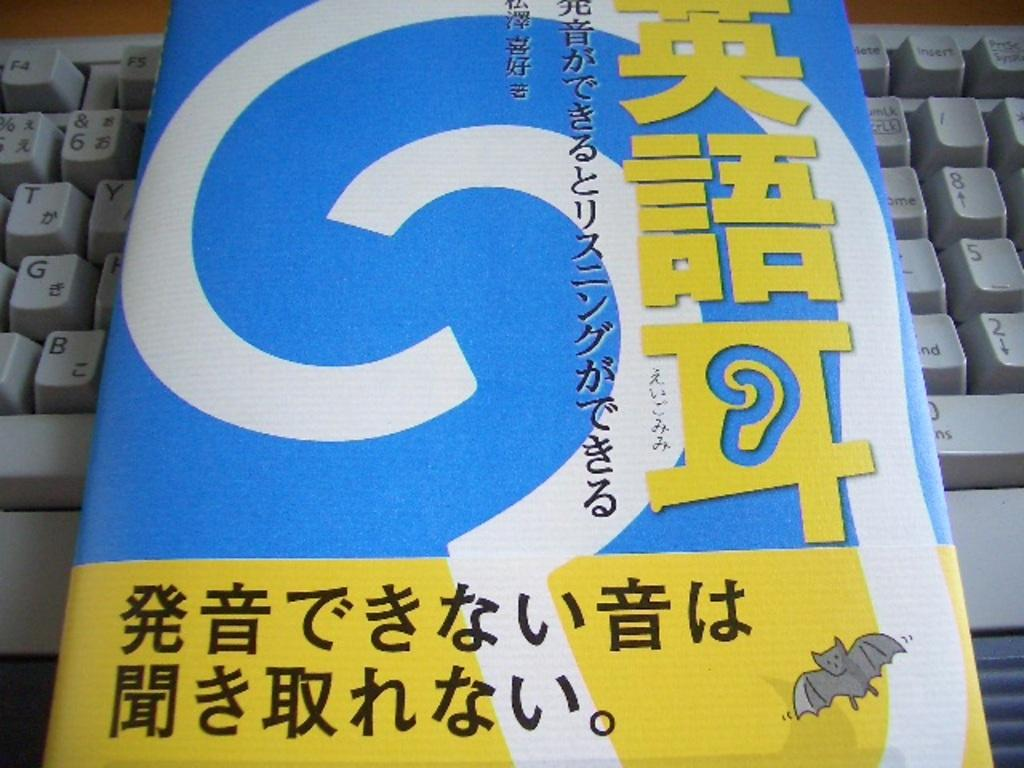<image>
Provide a brief description of the given image. A book with Asian writing on it on top of a keyboard with the number 8, 5, and 2 visible. 